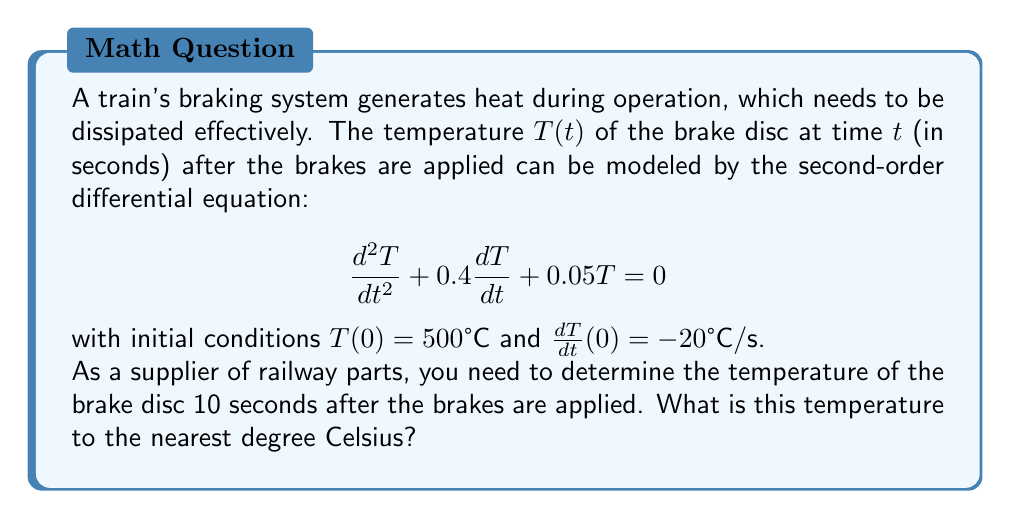Can you answer this question? To solve this problem, we need to follow these steps:

1) The general solution for this second-order linear differential equation is:

   $$T(t) = C_1e^{r_1t} + C_2e^{r_2t}$$

   where $r_1$ and $r_2$ are the roots of the characteristic equation:

   $$r^2 + 0.4r + 0.05 = 0$$

2) Solving the characteristic equation:
   
   $$r = \frac{-0.4 \pm \sqrt{0.4^2 - 4(0.05)}}{2} = \frac{-0.4 \pm \sqrt{0.16 - 0.2}}{2} = \frac{-0.4 \pm \sqrt{-0.04}}{2}$$

   $$r = -0.2 \pm 0.1i$$

3) Therefore, the general solution is:

   $$T(t) = e^{-0.2t}(C_1\cos(0.1t) + C_2\sin(0.1t))$$

4) Using the initial conditions:

   $T(0) = 500$, so $C_1 = 500$

   $\frac{dT}{dt}(0) = -20$, so $-0.2C_1 + 0.1C_2 = -20$

   Substituting $C_1 = 500$:
   
   $-100 + 0.1C_2 = -20$
   $0.1C_2 = 80$
   $C_2 = 800$

5) The particular solution is:

   $$T(t) = e^{-0.2t}(500\cos(0.1t) + 800\sin(0.1t))$$

6) To find $T(10)$, we substitute $t = 10$:

   $$T(10) = e^{-2}(500\cos(1) + 800\sin(1))$$

7) Calculating this value:

   $$T(10) = 0.1353 * (500 * 0.5403 + 800 * 0.8415) = 135.8°C$$

8) Rounding to the nearest degree:

   $$T(10) \approx 136°C$$
Answer: 136°C 